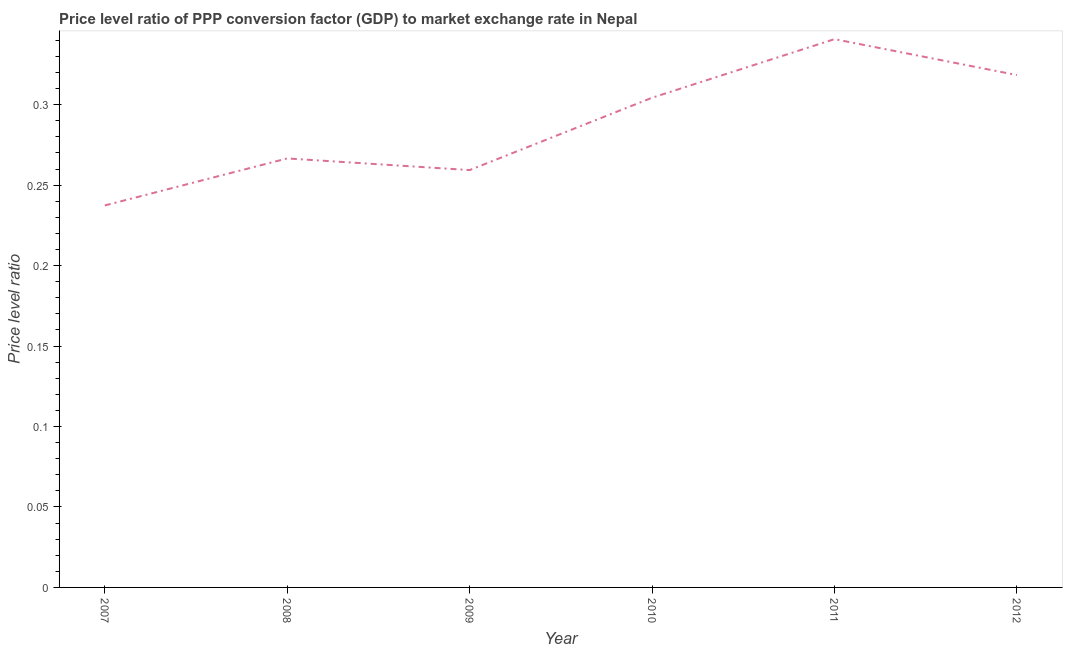What is the price level ratio in 2008?
Offer a very short reply. 0.27. Across all years, what is the maximum price level ratio?
Provide a succinct answer. 0.34. Across all years, what is the minimum price level ratio?
Keep it short and to the point. 0.24. In which year was the price level ratio maximum?
Provide a succinct answer. 2011. What is the sum of the price level ratio?
Provide a short and direct response. 1.73. What is the difference between the price level ratio in 2009 and 2011?
Ensure brevity in your answer.  -0.08. What is the average price level ratio per year?
Ensure brevity in your answer.  0.29. What is the median price level ratio?
Give a very brief answer. 0.29. In how many years, is the price level ratio greater than 0.24000000000000002 ?
Ensure brevity in your answer.  5. What is the ratio of the price level ratio in 2009 to that in 2010?
Offer a terse response. 0.85. Is the price level ratio in 2008 less than that in 2010?
Your response must be concise. Yes. What is the difference between the highest and the second highest price level ratio?
Provide a short and direct response. 0.02. Is the sum of the price level ratio in 2007 and 2010 greater than the maximum price level ratio across all years?
Offer a very short reply. Yes. What is the difference between the highest and the lowest price level ratio?
Your answer should be compact. 0.1. In how many years, is the price level ratio greater than the average price level ratio taken over all years?
Offer a terse response. 3. How many lines are there?
Offer a very short reply. 1. Are the values on the major ticks of Y-axis written in scientific E-notation?
Ensure brevity in your answer.  No. Does the graph contain grids?
Ensure brevity in your answer.  No. What is the title of the graph?
Give a very brief answer. Price level ratio of PPP conversion factor (GDP) to market exchange rate in Nepal. What is the label or title of the X-axis?
Offer a terse response. Year. What is the label or title of the Y-axis?
Offer a very short reply. Price level ratio. What is the Price level ratio in 2007?
Make the answer very short. 0.24. What is the Price level ratio in 2008?
Your answer should be very brief. 0.27. What is the Price level ratio in 2009?
Give a very brief answer. 0.26. What is the Price level ratio in 2010?
Provide a succinct answer. 0.3. What is the Price level ratio of 2011?
Your answer should be very brief. 0.34. What is the Price level ratio in 2012?
Your response must be concise. 0.32. What is the difference between the Price level ratio in 2007 and 2008?
Your answer should be very brief. -0.03. What is the difference between the Price level ratio in 2007 and 2009?
Keep it short and to the point. -0.02. What is the difference between the Price level ratio in 2007 and 2010?
Offer a terse response. -0.07. What is the difference between the Price level ratio in 2007 and 2011?
Your answer should be compact. -0.1. What is the difference between the Price level ratio in 2007 and 2012?
Provide a short and direct response. -0.08. What is the difference between the Price level ratio in 2008 and 2009?
Ensure brevity in your answer.  0.01. What is the difference between the Price level ratio in 2008 and 2010?
Give a very brief answer. -0.04. What is the difference between the Price level ratio in 2008 and 2011?
Offer a very short reply. -0.07. What is the difference between the Price level ratio in 2008 and 2012?
Keep it short and to the point. -0.05. What is the difference between the Price level ratio in 2009 and 2010?
Provide a succinct answer. -0.04. What is the difference between the Price level ratio in 2009 and 2011?
Your answer should be compact. -0.08. What is the difference between the Price level ratio in 2009 and 2012?
Provide a succinct answer. -0.06. What is the difference between the Price level ratio in 2010 and 2011?
Your answer should be very brief. -0.04. What is the difference between the Price level ratio in 2010 and 2012?
Your answer should be compact. -0.01. What is the difference between the Price level ratio in 2011 and 2012?
Your response must be concise. 0.02. What is the ratio of the Price level ratio in 2007 to that in 2008?
Offer a very short reply. 0.89. What is the ratio of the Price level ratio in 2007 to that in 2009?
Keep it short and to the point. 0.92. What is the ratio of the Price level ratio in 2007 to that in 2010?
Keep it short and to the point. 0.78. What is the ratio of the Price level ratio in 2007 to that in 2011?
Keep it short and to the point. 0.7. What is the ratio of the Price level ratio in 2007 to that in 2012?
Give a very brief answer. 0.75. What is the ratio of the Price level ratio in 2008 to that in 2009?
Provide a short and direct response. 1.03. What is the ratio of the Price level ratio in 2008 to that in 2010?
Your response must be concise. 0.88. What is the ratio of the Price level ratio in 2008 to that in 2011?
Make the answer very short. 0.78. What is the ratio of the Price level ratio in 2008 to that in 2012?
Keep it short and to the point. 0.84. What is the ratio of the Price level ratio in 2009 to that in 2010?
Provide a short and direct response. 0.85. What is the ratio of the Price level ratio in 2009 to that in 2011?
Give a very brief answer. 0.76. What is the ratio of the Price level ratio in 2009 to that in 2012?
Provide a short and direct response. 0.81. What is the ratio of the Price level ratio in 2010 to that in 2011?
Your answer should be very brief. 0.89. What is the ratio of the Price level ratio in 2010 to that in 2012?
Offer a terse response. 0.96. What is the ratio of the Price level ratio in 2011 to that in 2012?
Provide a short and direct response. 1.07. 